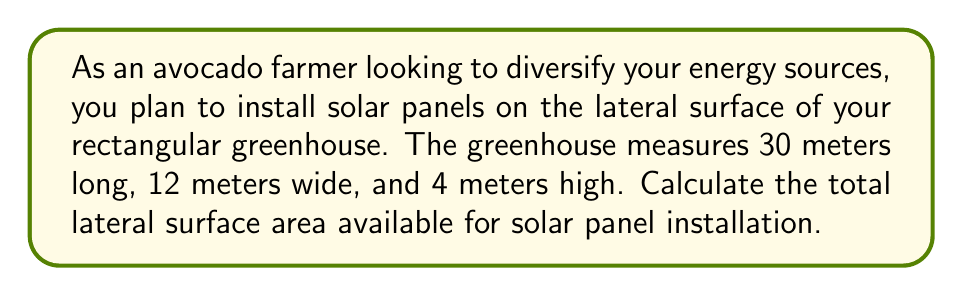Help me with this question. To solve this problem, we need to follow these steps:

1. Identify the lateral surfaces of the greenhouse:
   The lateral surfaces are the four vertical sides of the rectangular greenhouse.

2. Calculate the area of each lateral surface:
   a) Long sides (2 of them):
      Area = length × height
      $A_{\text{long}} = 30 \text{ m} \times 4 \text{ m} = 120 \text{ m}^2$
   
   b) Short sides (2 of them):
      Area = width × height
      $A_{\text{short}} = 12 \text{ m} \times 4 \text{ m} = 48 \text{ m}^2$

3. Calculate the total lateral surface area:
   Total area = 2 × (Area of long side + Area of short side)
   $A_{\text{total}} = 2 \times (120 \text{ m}^2 + 48 \text{ m}^2)$
   $A_{\text{total}} = 2 \times 168 \text{ m}^2 = 336 \text{ m}^2$

[asy]
import three;

size(200);
currentprojection=perspective(6,3,2);

draw((0,0,0)--(30,0,0)--(30,12,0)--(0,12,0)--cycle);
draw((0,0,4)--(30,0,4)--(30,12,4)--(0,12,4)--cycle);
draw((0,0,0)--(0,0,4));
draw((30,0,0)--(30,0,4));
draw((30,12,0)--(30,12,4));
draw((0,12,0)--(0,12,4));

label("30 m", (15,0,0), S);
label("12 m", (30,6,0), E);
label("4 m", (0,0,2), W);
[/asy]

The diagram above illustrates the dimensions of the greenhouse.
Answer: The total lateral surface area available for solar panel installation is $336 \text{ m}^2$. 